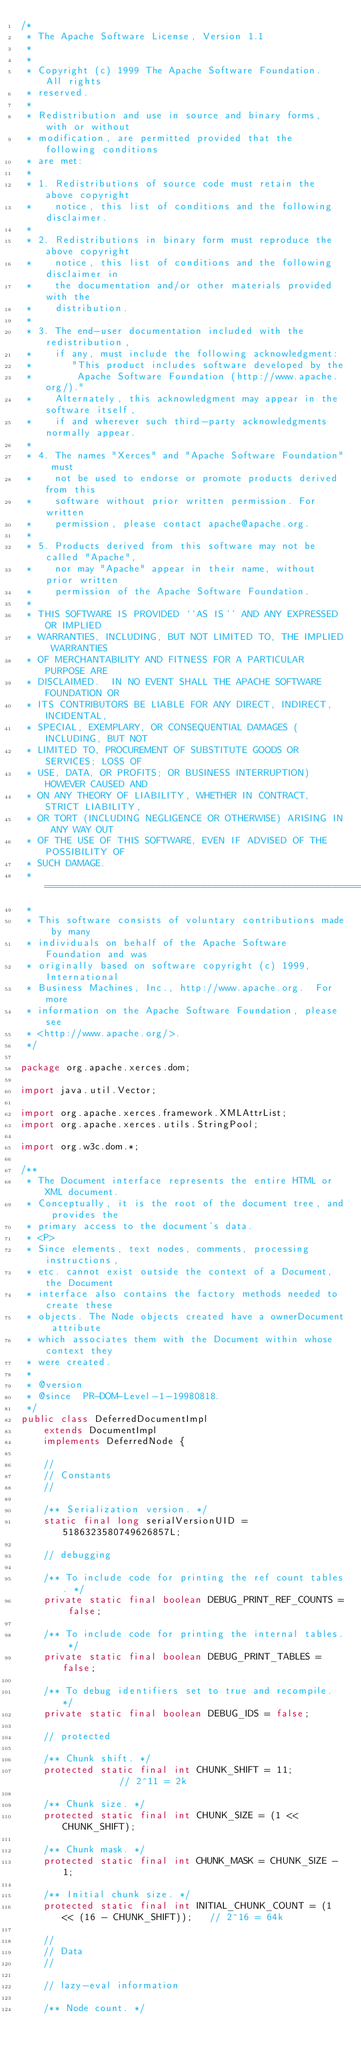<code> <loc_0><loc_0><loc_500><loc_500><_Java_>/*
 * The Apache Software License, Version 1.1
 *
 *
 * Copyright (c) 1999 The Apache Software Foundation.  All rights
 * reserved.
 *
 * Redistribution and use in source and binary forms, with or without
 * modification, are permitted provided that the following conditions
 * are met:
 *
 * 1. Redistributions of source code must retain the above copyright
 *    notice, this list of conditions and the following disclaimer.
 *
 * 2. Redistributions in binary form must reproduce the above copyright
 *    notice, this list of conditions and the following disclaimer in
 *    the documentation and/or other materials provided with the
 *    distribution.
 *
 * 3. The end-user documentation included with the redistribution,
 *    if any, must include the following acknowledgment:
 *       "This product includes software developed by the
 *        Apache Software Foundation (http://www.apache.org/)."
 *    Alternately, this acknowledgment may appear in the software itself,
 *    if and wherever such third-party acknowledgments normally appear.
 *
 * 4. The names "Xerces" and "Apache Software Foundation" must
 *    not be used to endorse or promote products derived from this
 *    software without prior written permission. For written
 *    permission, please contact apache@apache.org.
 *
 * 5. Products derived from this software may not be called "Apache",
 *    nor may "Apache" appear in their name, without prior written
 *    permission of the Apache Software Foundation.
 *
 * THIS SOFTWARE IS PROVIDED ``AS IS'' AND ANY EXPRESSED OR IMPLIED
 * WARRANTIES, INCLUDING, BUT NOT LIMITED TO, THE IMPLIED WARRANTIES
 * OF MERCHANTABILITY AND FITNESS FOR A PARTICULAR PURPOSE ARE
 * DISCLAIMED.  IN NO EVENT SHALL THE APACHE SOFTWARE FOUNDATION OR
 * ITS CONTRIBUTORS BE LIABLE FOR ANY DIRECT, INDIRECT, INCIDENTAL,
 * SPECIAL, EXEMPLARY, OR CONSEQUENTIAL DAMAGES (INCLUDING, BUT NOT
 * LIMITED TO, PROCUREMENT OF SUBSTITUTE GOODS OR SERVICES; LOSS OF
 * USE, DATA, OR PROFITS; OR BUSINESS INTERRUPTION) HOWEVER CAUSED AND
 * ON ANY THEORY OF LIABILITY, WHETHER IN CONTRACT, STRICT LIABILITY,
 * OR TORT (INCLUDING NEGLIGENCE OR OTHERWISE) ARISING IN ANY WAY OUT
 * OF THE USE OF THIS SOFTWARE, EVEN IF ADVISED OF THE POSSIBILITY OF
 * SUCH DAMAGE.
 * ====================================================================
 *
 * This software consists of voluntary contributions made by many
 * individuals on behalf of the Apache Software Foundation and was
 * originally based on software copyright (c) 1999, International
 * Business Machines, Inc., http://www.apache.org.  For more
 * information on the Apache Software Foundation, please see
 * <http://www.apache.org/>.
 */

package org.apache.xerces.dom;

import java.util.Vector;

import org.apache.xerces.framework.XMLAttrList;
import org.apache.xerces.utils.StringPool;

import org.w3c.dom.*;

/**
 * The Document interface represents the entire HTML or XML document.
 * Conceptually, it is the root of the document tree, and provides the
 * primary access to the document's data.
 * <P>
 * Since elements, text nodes, comments, processing instructions,
 * etc. cannot exist outside the context of a Document, the Document
 * interface also contains the factory methods needed to create these
 * objects. The Node objects created have a ownerDocument attribute
 * which associates them with the Document within whose context they
 * were created.
 *
 * @version
 * @since  PR-DOM-Level-1-19980818.
 */
public class DeferredDocumentImpl
    extends DocumentImpl
    implements DeferredNode {

    //
    // Constants
    //

    /** Serialization version. */
    static final long serialVersionUID = 5186323580749626857L;

    // debugging

    /** To include code for printing the ref count tables. */
    private static final boolean DEBUG_PRINT_REF_COUNTS = false;

    /** To include code for printing the internal tables. */
    private static final boolean DEBUG_PRINT_TABLES = false;

    /** To debug identifiers set to true and recompile. */
    private static final boolean DEBUG_IDS = false;

    // protected

    /** Chunk shift. */
    protected static final int CHUNK_SHIFT = 11;           // 2^11 = 2k

    /** Chunk size. */
    protected static final int CHUNK_SIZE = (1 << CHUNK_SHIFT);

    /** Chunk mask. */
    protected static final int CHUNK_MASK = CHUNK_SIZE - 1;

    /** Initial chunk size. */
    protected static final int INITIAL_CHUNK_COUNT = (1 << (16 - CHUNK_SHIFT));   // 2^16 = 64k

    //
    // Data
    //

    // lazy-eval information

    /** Node count. */</code> 